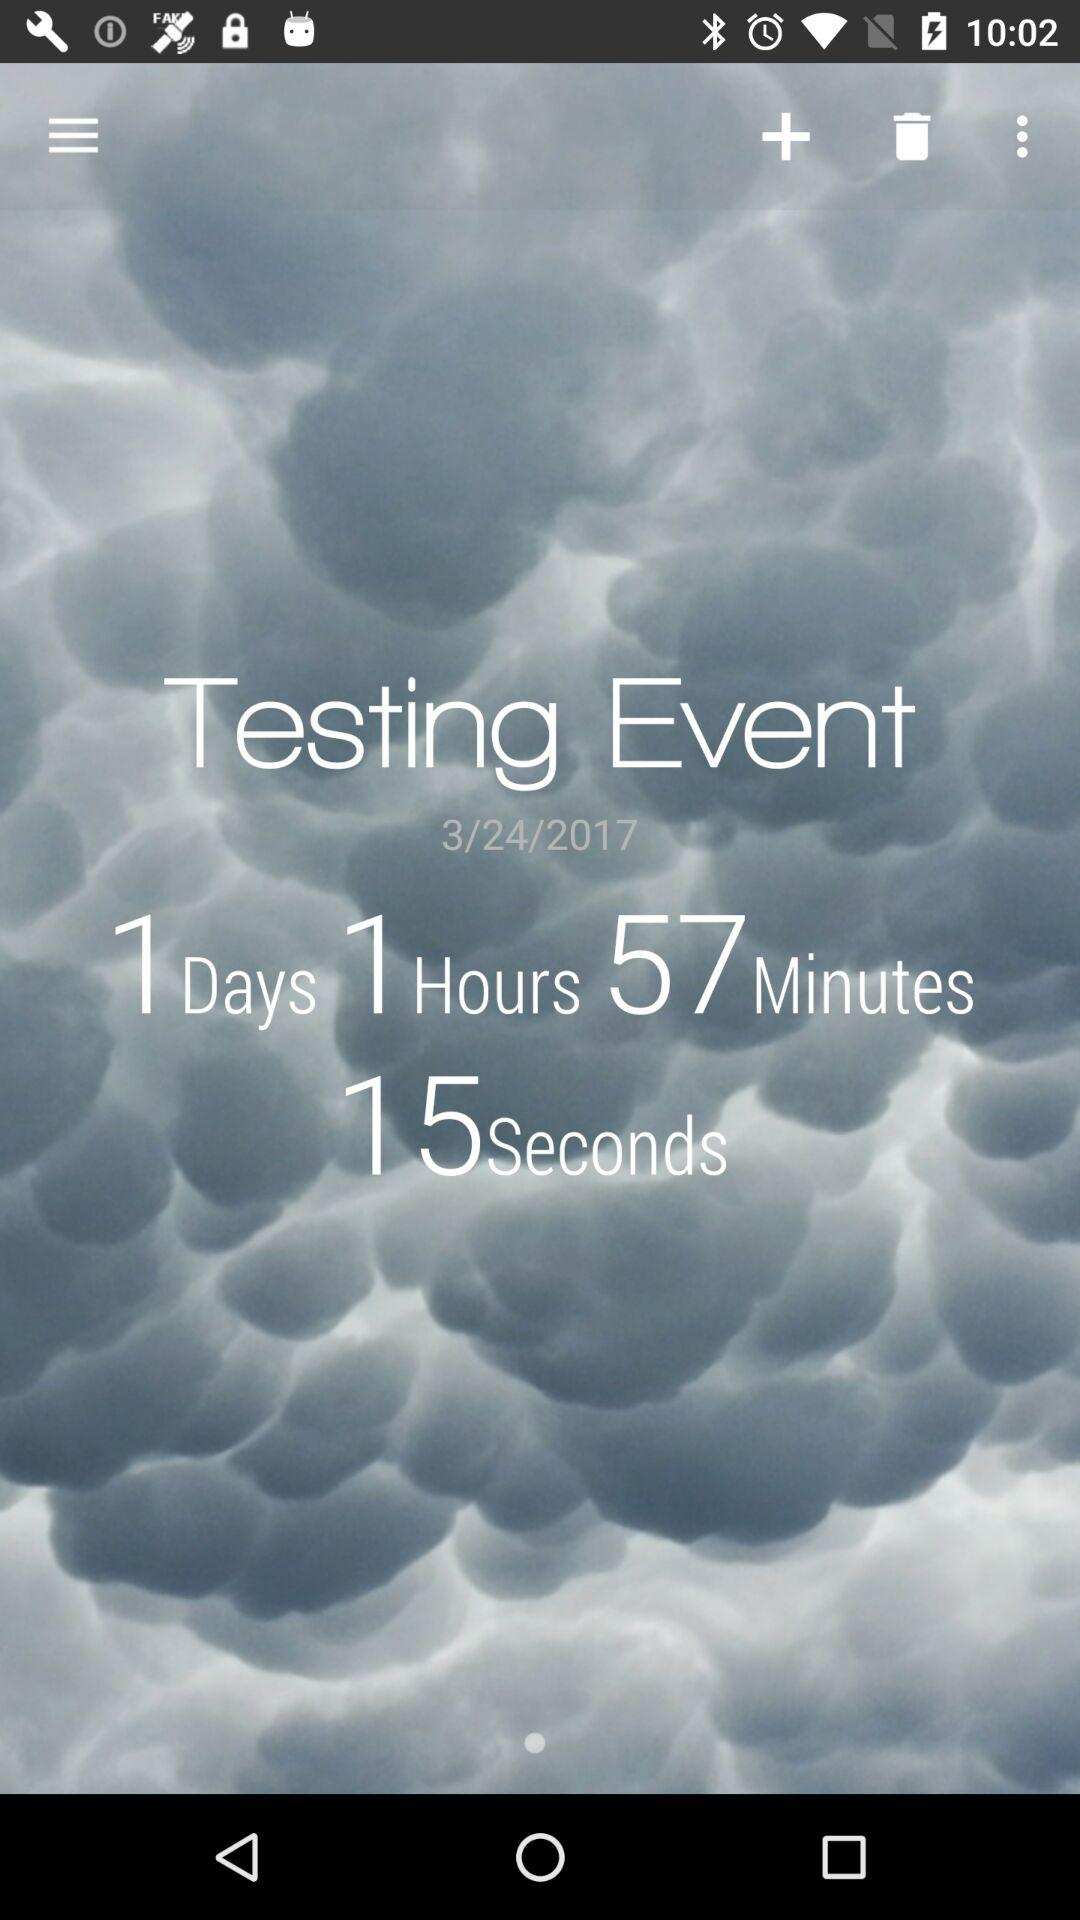How many more days are left until the event?
Answer the question using a single word or phrase. 1 